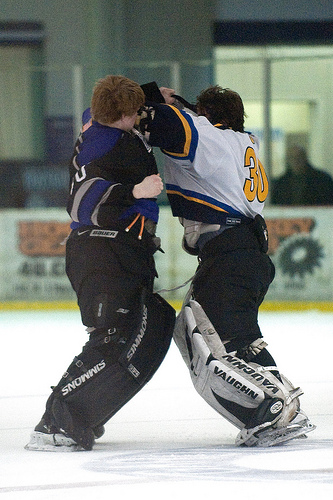<image>
Is there a man on the man? No. The man is not positioned on the man. They may be near each other, but the man is not supported by or resting on top of the man. 